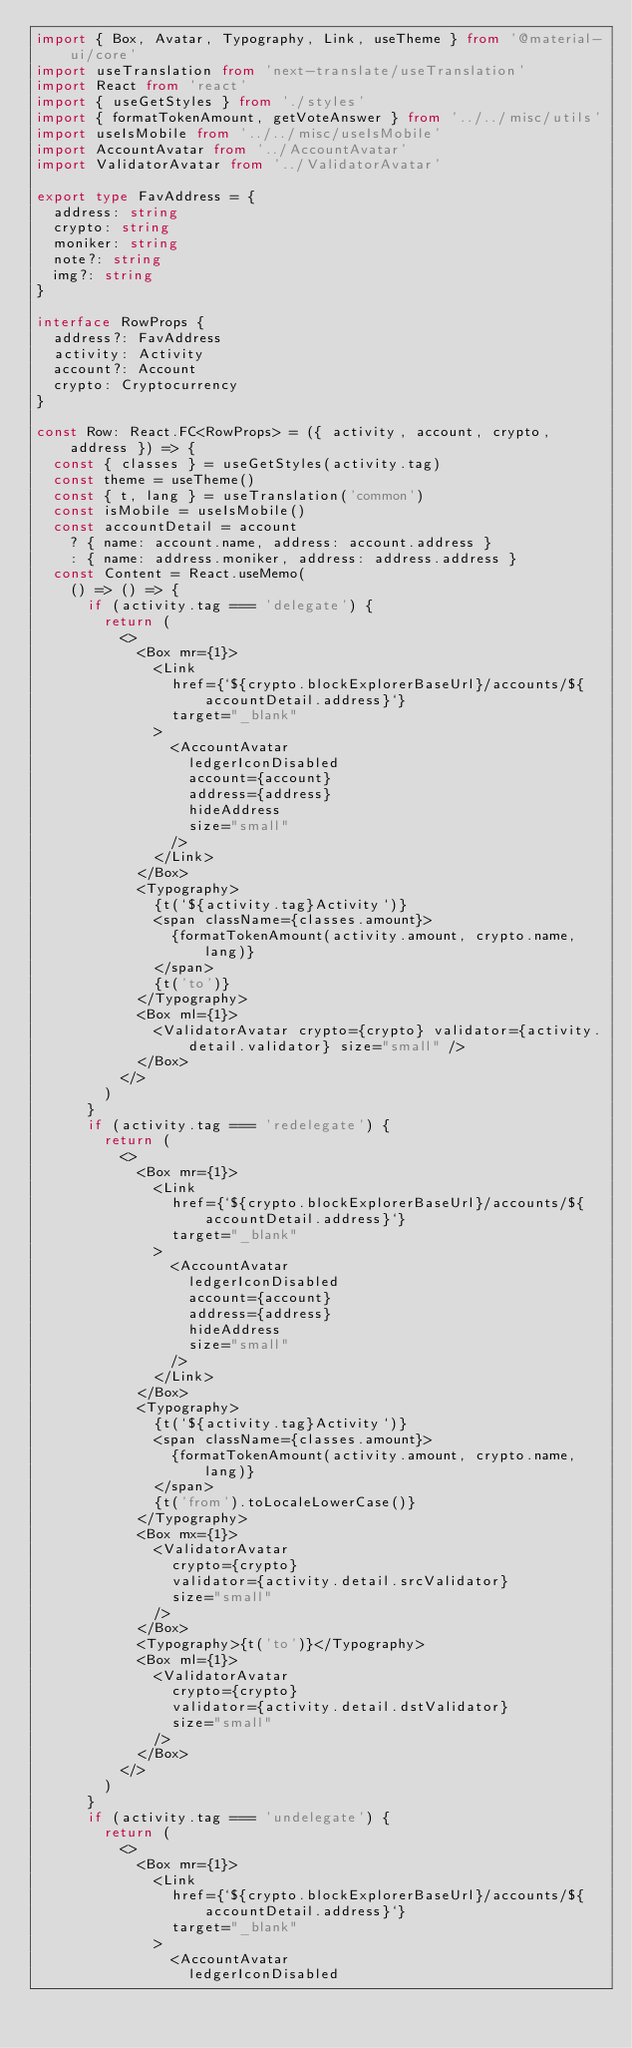Convert code to text. <code><loc_0><loc_0><loc_500><loc_500><_TypeScript_>import { Box, Avatar, Typography, Link, useTheme } from '@material-ui/core'
import useTranslation from 'next-translate/useTranslation'
import React from 'react'
import { useGetStyles } from './styles'
import { formatTokenAmount, getVoteAnswer } from '../../misc/utils'
import useIsMobile from '../../misc/useIsMobile'
import AccountAvatar from '../AccountAvatar'
import ValidatorAvatar from '../ValidatorAvatar'

export type FavAddress = {
  address: string
  crypto: string
  moniker: string
  note?: string
  img?: string
}

interface RowProps {
  address?: FavAddress
  activity: Activity
  account?: Account
  crypto: Cryptocurrency
}

const Row: React.FC<RowProps> = ({ activity, account, crypto, address }) => {
  const { classes } = useGetStyles(activity.tag)
  const theme = useTheme()
  const { t, lang } = useTranslation('common')
  const isMobile = useIsMobile()
  const accountDetail = account
    ? { name: account.name, address: account.address }
    : { name: address.moniker, address: address.address }
  const Content = React.useMemo(
    () => () => {
      if (activity.tag === 'delegate') {
        return (
          <>
            <Box mr={1}>
              <Link
                href={`${crypto.blockExplorerBaseUrl}/accounts/${accountDetail.address}`}
                target="_blank"
              >
                <AccountAvatar
                  ledgerIconDisabled
                  account={account}
                  address={address}
                  hideAddress
                  size="small"
                />
              </Link>
            </Box>
            <Typography>
              {t(`${activity.tag}Activity`)}
              <span className={classes.amount}>
                {formatTokenAmount(activity.amount, crypto.name, lang)}
              </span>
              {t('to')}
            </Typography>
            <Box ml={1}>
              <ValidatorAvatar crypto={crypto} validator={activity.detail.validator} size="small" />
            </Box>
          </>
        )
      }
      if (activity.tag === 'redelegate') {
        return (
          <>
            <Box mr={1}>
              <Link
                href={`${crypto.blockExplorerBaseUrl}/accounts/${accountDetail.address}`}
                target="_blank"
              >
                <AccountAvatar
                  ledgerIconDisabled
                  account={account}
                  address={address}
                  hideAddress
                  size="small"
                />
              </Link>
            </Box>
            <Typography>
              {t(`${activity.tag}Activity`)}
              <span className={classes.amount}>
                {formatTokenAmount(activity.amount, crypto.name, lang)}
              </span>
              {t('from').toLocaleLowerCase()}
            </Typography>
            <Box mx={1}>
              <ValidatorAvatar
                crypto={crypto}
                validator={activity.detail.srcValidator}
                size="small"
              />
            </Box>
            <Typography>{t('to')}</Typography>
            <Box ml={1}>
              <ValidatorAvatar
                crypto={crypto}
                validator={activity.detail.dstValidator}
                size="small"
              />
            </Box>
          </>
        )
      }
      if (activity.tag === 'undelegate') {
        return (
          <>
            <Box mr={1}>
              <Link
                href={`${crypto.blockExplorerBaseUrl}/accounts/${accountDetail.address}`}
                target="_blank"
              >
                <AccountAvatar
                  ledgerIconDisabled</code> 